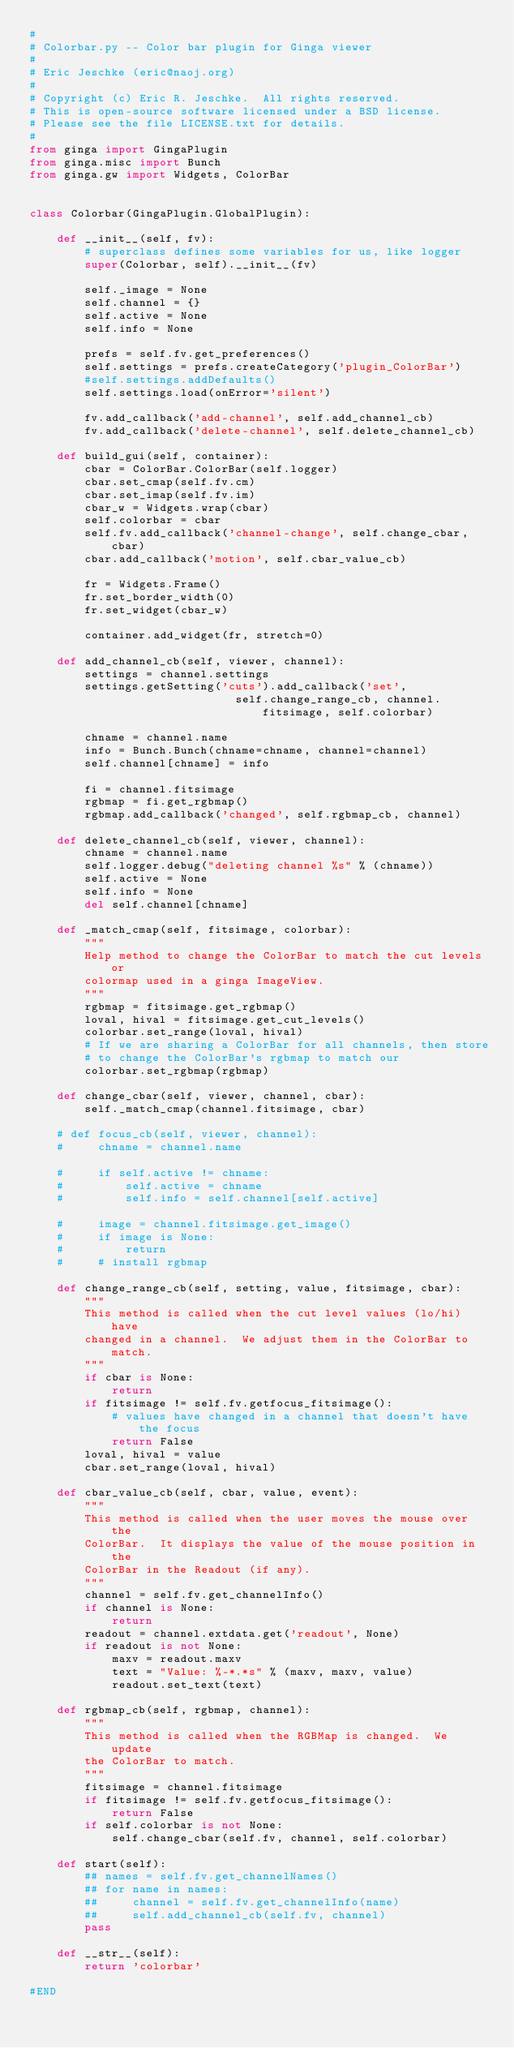<code> <loc_0><loc_0><loc_500><loc_500><_Python_>#
# Colorbar.py -- Color bar plugin for Ginga viewer
#
# Eric Jeschke (eric@naoj.org)
#
# Copyright (c) Eric R. Jeschke.  All rights reserved.
# This is open-source software licensed under a BSD license.
# Please see the file LICENSE.txt for details.
#
from ginga import GingaPlugin
from ginga.misc import Bunch
from ginga.gw import Widgets, ColorBar


class Colorbar(GingaPlugin.GlobalPlugin):

    def __init__(self, fv):
        # superclass defines some variables for us, like logger
        super(Colorbar, self).__init__(fv)

        self._image = None
        self.channel = {}
        self.active = None
        self.info = None

        prefs = self.fv.get_preferences()
        self.settings = prefs.createCategory('plugin_ColorBar')
        #self.settings.addDefaults()
        self.settings.load(onError='silent')

        fv.add_callback('add-channel', self.add_channel_cb)
        fv.add_callback('delete-channel', self.delete_channel_cb)

    def build_gui(self, container):
        cbar = ColorBar.ColorBar(self.logger)
        cbar.set_cmap(self.fv.cm)
        cbar.set_imap(self.fv.im)
        cbar_w = Widgets.wrap(cbar)
        self.colorbar = cbar
        self.fv.add_callback('channel-change', self.change_cbar, cbar)
        cbar.add_callback('motion', self.cbar_value_cb)

        fr = Widgets.Frame()
        fr.set_border_width(0)
        fr.set_widget(cbar_w)

        container.add_widget(fr, stretch=0)

    def add_channel_cb(self, viewer, channel):
        settings = channel.settings
        settings.getSetting('cuts').add_callback('set',
                              self.change_range_cb, channel.fitsimage, self.colorbar)

        chname = channel.name
        info = Bunch.Bunch(chname=chname, channel=channel)
        self.channel[chname] = info

        fi = channel.fitsimage
        rgbmap = fi.get_rgbmap()
        rgbmap.add_callback('changed', self.rgbmap_cb, channel)

    def delete_channel_cb(self, viewer, channel):
        chname = channel.name
        self.logger.debug("deleting channel %s" % (chname))
        self.active = None
        self.info = None
        del self.channel[chname]

    def _match_cmap(self, fitsimage, colorbar):
        """
        Help method to change the ColorBar to match the cut levels or
        colormap used in a ginga ImageView.
        """
        rgbmap = fitsimage.get_rgbmap()
        loval, hival = fitsimage.get_cut_levels()
        colorbar.set_range(loval, hival)
        # If we are sharing a ColorBar for all channels, then store
        # to change the ColorBar's rgbmap to match our
        colorbar.set_rgbmap(rgbmap)

    def change_cbar(self, viewer, channel, cbar):
        self._match_cmap(channel.fitsimage, cbar)

    # def focus_cb(self, viewer, channel):
    #     chname = channel.name

    #     if self.active != chname:
    #         self.active = chname
    #         self.info = self.channel[self.active]

    #     image = channel.fitsimage.get_image()
    #     if image is None:
    #         return
    #     # install rgbmap

    def change_range_cb(self, setting, value, fitsimage, cbar):
        """
        This method is called when the cut level values (lo/hi) have
        changed in a channel.  We adjust them in the ColorBar to match.
        """
        if cbar is None:
            return
        if fitsimage != self.fv.getfocus_fitsimage():
            # values have changed in a channel that doesn't have the focus
            return False
        loval, hival = value
        cbar.set_range(loval, hival)

    def cbar_value_cb(self, cbar, value, event):
        """
        This method is called when the user moves the mouse over the
        ColorBar.  It displays the value of the mouse position in the
        ColorBar in the Readout (if any).
        """
        channel = self.fv.get_channelInfo()
        if channel is None:
            return
        readout = channel.extdata.get('readout', None)
        if readout is not None:
            maxv = readout.maxv
            text = "Value: %-*.*s" % (maxv, maxv, value)
            readout.set_text(text)

    def rgbmap_cb(self, rgbmap, channel):
        """
        This method is called when the RGBMap is changed.  We update
        the ColorBar to match.
        """
        fitsimage = channel.fitsimage
        if fitsimage != self.fv.getfocus_fitsimage():
            return False
        if self.colorbar is not None:
            self.change_cbar(self.fv, channel, self.colorbar)

    def start(self):
        ## names = self.fv.get_channelNames()
        ## for name in names:
        ##     channel = self.fv.get_channelInfo(name)
        ##     self.add_channel_cb(self.fv, channel)
        pass

    def __str__(self):
        return 'colorbar'

#END
</code> 